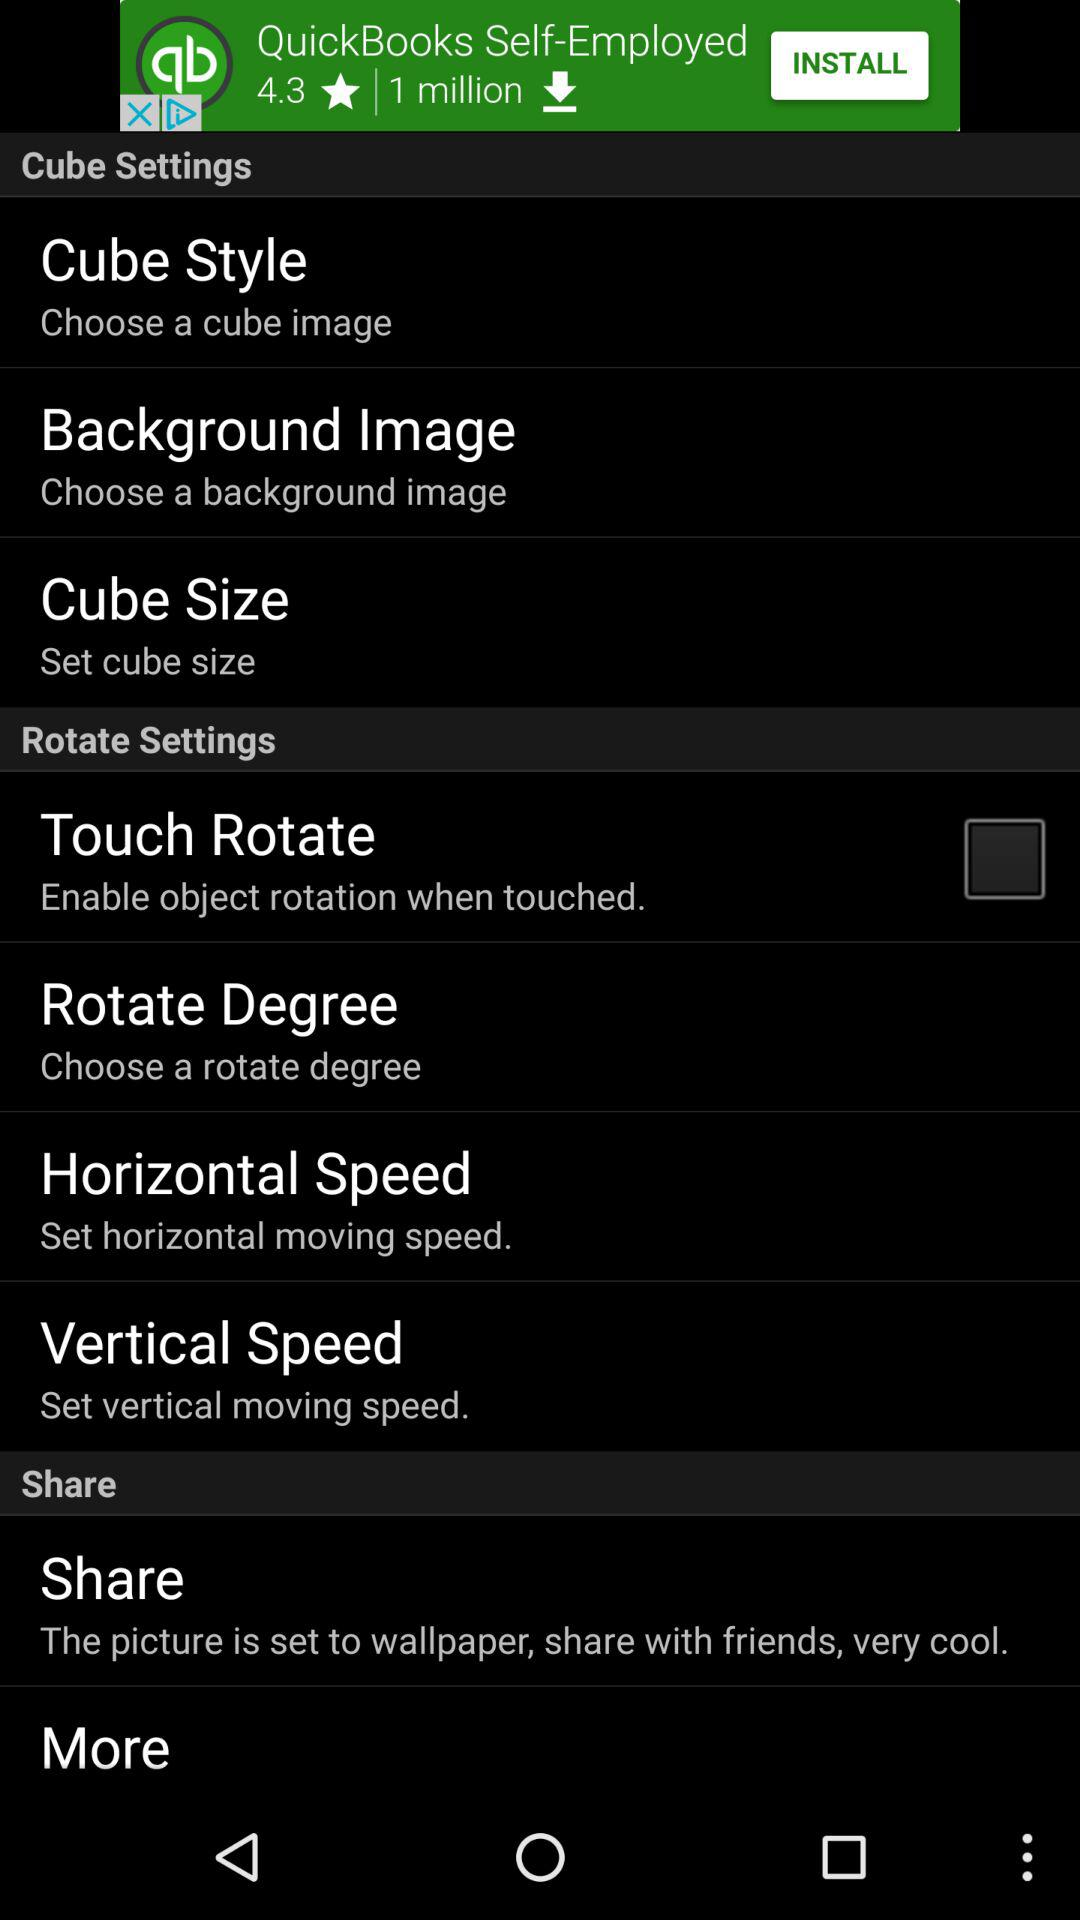What is the current status of the "Touch Rotate" setting? The current status of the "Touch Rotate" setting is "off". 